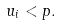Convert formula to latex. <formula><loc_0><loc_0><loc_500><loc_500>u _ { i } < p .</formula> 